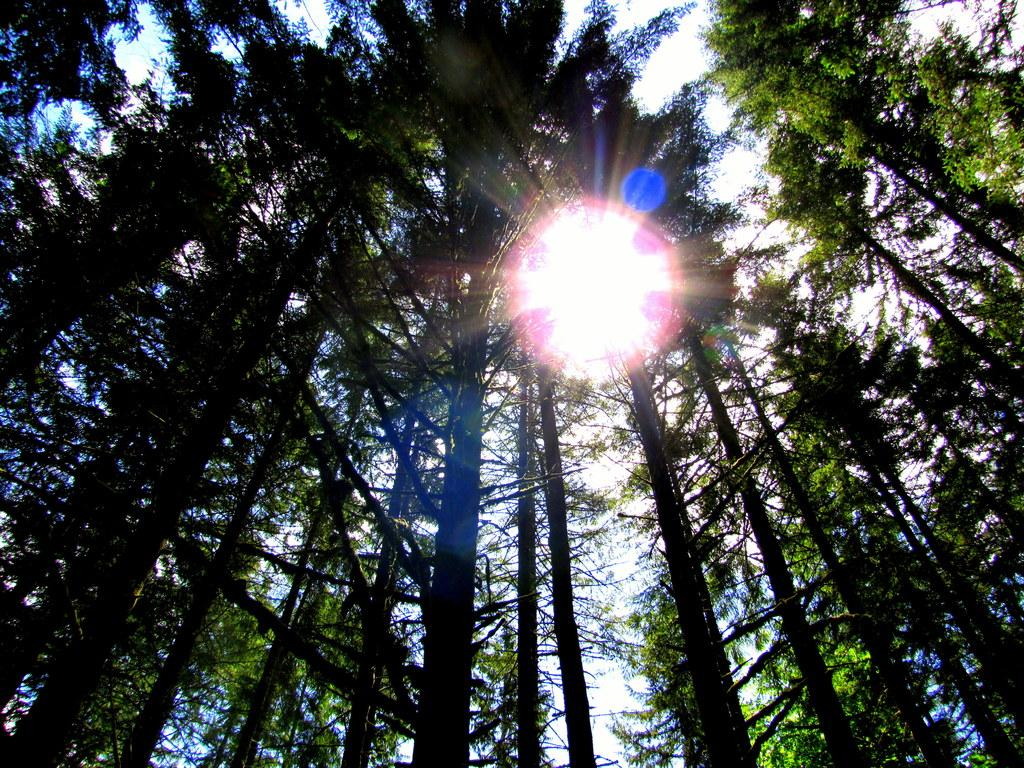What type of vegetation is present in the image? There are many trees in the image. What is the color of the sky in the image? The sky is white in the image. Can you identify any celestial bodies in the image? Yes, the sun is visible in the image. How many boys are jumping in the image? There are no boys or jumping depicted in the image; it features trees, a white sky, and the sun. What type of bone is visible in the image? There is no bone present in the image. 